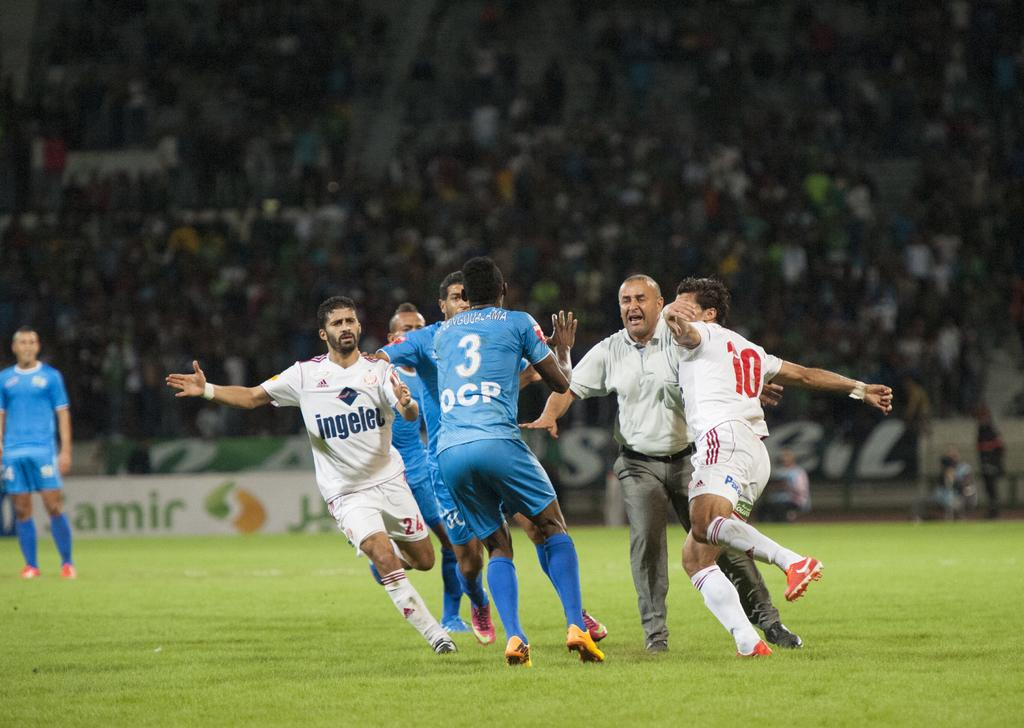Provide a one-sentence caption for the provided image. Soccer players with the number 3 and number 10 seem to be about to collide. 